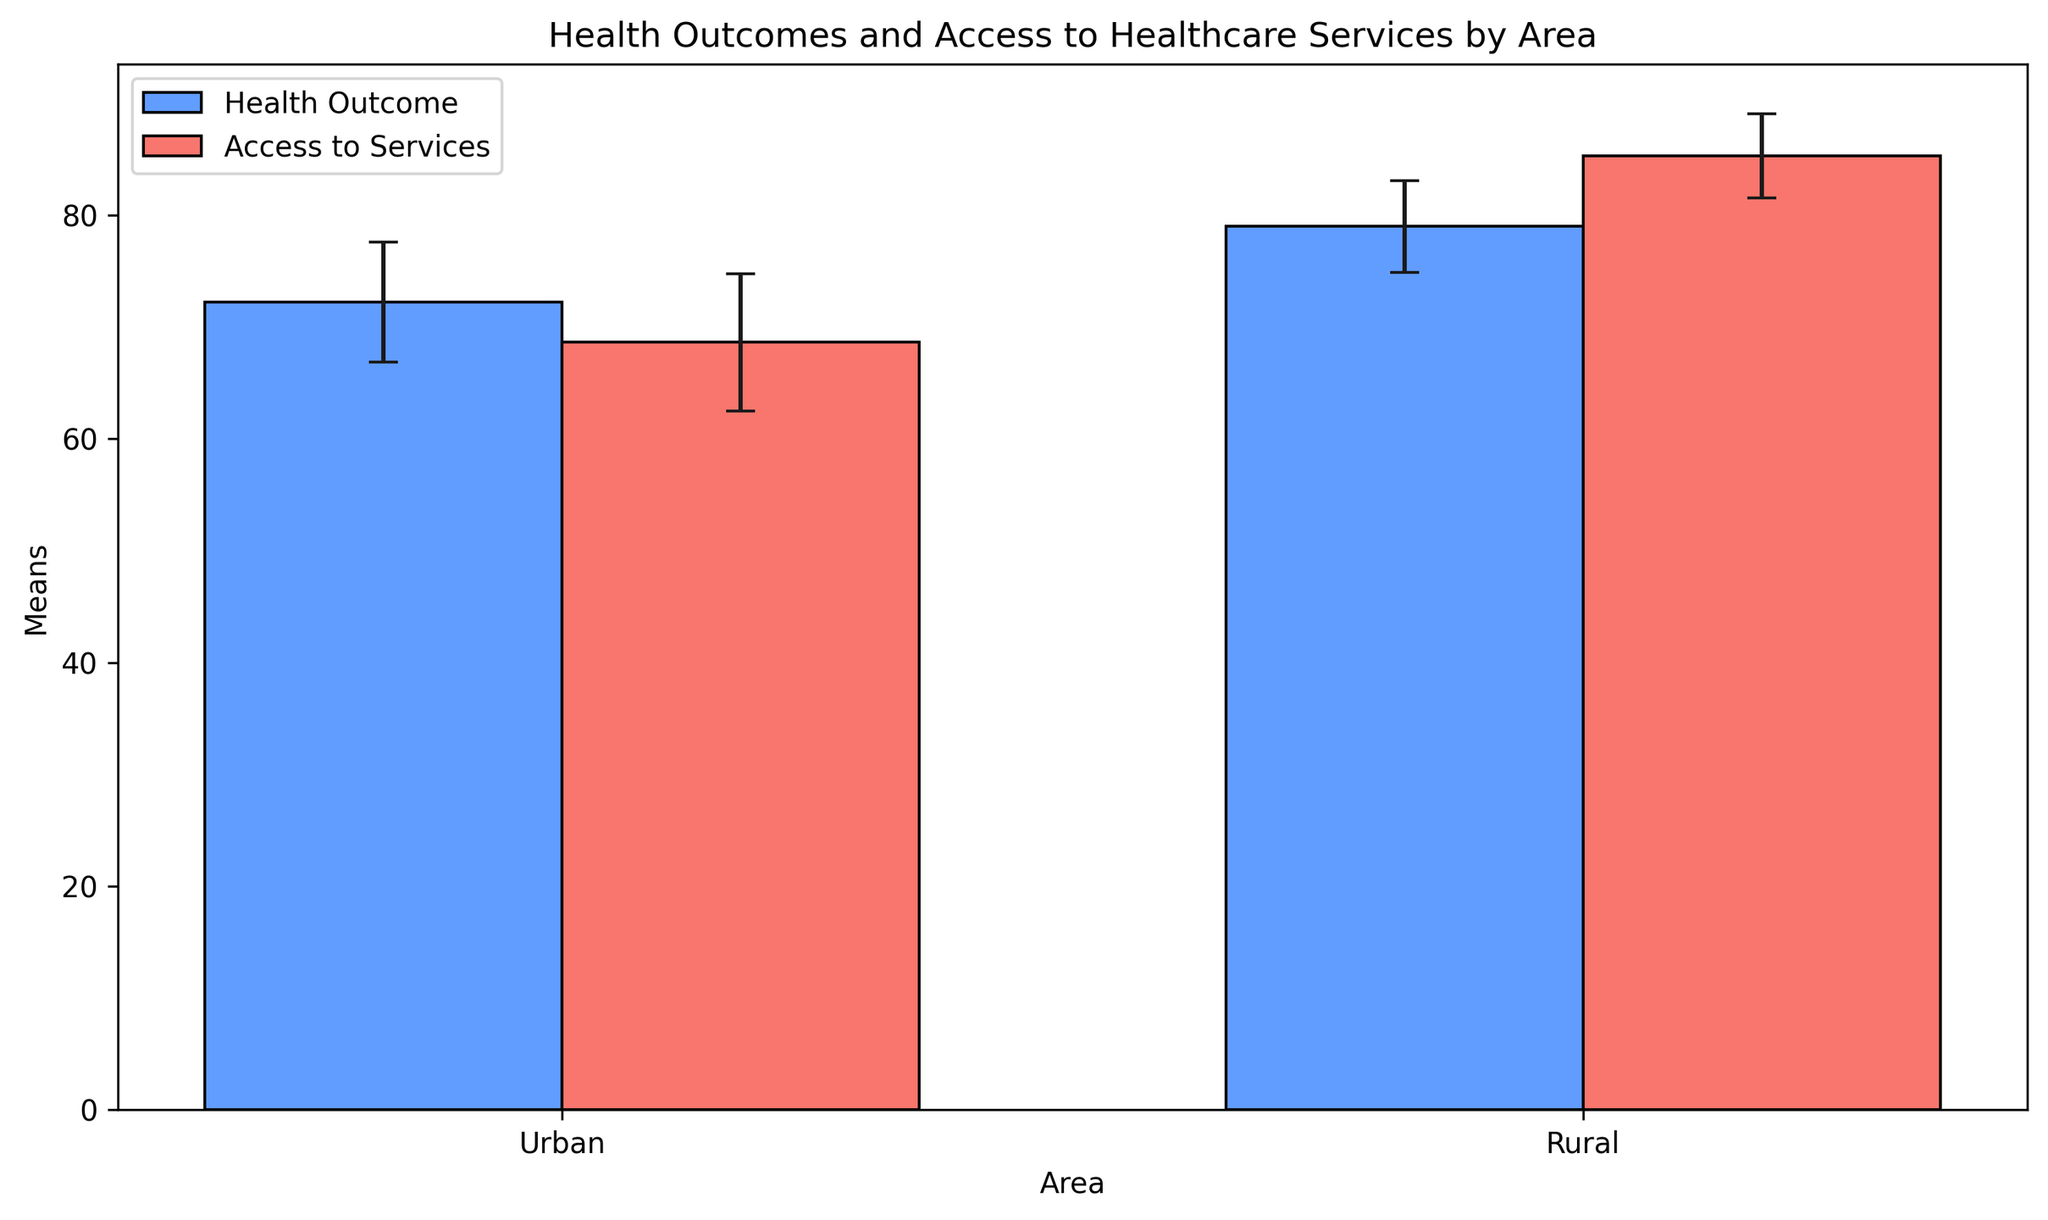What's the average health outcome mean for Urban areas? To find the average health outcome mean for Urban areas, add all the health outcome means for Urban areas (78.4, 79.2, 80.1, 77.9, 78.7, 79.6) and then divide by the number of data points (6). So, (78.4 + 79.2 + 80.1 + 77.9 + 78.7 + 79.6) / 6 = 78.98.
Answer: 78.98 How much higher is the average health outcome mean in Urban areas compared to Rural areas? Calculate the average health outcome for Urban areas (78.98) and Rural areas (72.2). Then, find the difference between the two values: 78.98 - 72.2 = 6.78.
Answer: 6.78 Which area has a higher mean value for access to healthcare services? Compare the mean values for access to healthcare services between Urban (85.3) and Rural (68.6) areas. The Urban area has a higher mean value.
Answer: Urban What color represents the bars for access to services in the figure? Observe the visual attributes of the bars in the figure. The bars representing access to services are colored in red.
Answer: Red What is the difference between the highest and lowest health outcome mean in Urban areas? Find the highest (80.1) and lowest (77.9) health outcome means for Urban areas. The difference is 80.1 - 77.9 = 2.2.
Answer: 2.2 Which area shows a wider error margin for access to healthcare services, and by how much? Compare the error margins for access to healthcare services in Urban (3.83) and Rural (6.13) areas. The Rural area shows a wider error margin by 6.13 - 3.83 = 2.3.
Answer: Rural, 2.3 Compare the average standard deviation for health outcomes between Urban and Rural areas. Which is higher? Calculate the average standard deviation for health outcomes in Urban areas (average of 4.1, 3.9, 4.5, 4.0, 3.8, and 4.2) and Rural areas (average of 5.3, 5.7, 5.1, 5.4, 5.2, and 5.5). Urban std = 4.083, Rural std = 5.37. The Rural area has a higher standard deviation.
Answer: Rural What is the average access to services mean in Rural areas? To calculate the average access to services mean for Rural areas, sum the access to services means for Rural areas (68.9, 67.5, 69.0, 70.1, 67.8, 68.5) and then divide by 6. So, (68.9 + 67.5 + 69.0 + 70.1 + 67.8 + 68.5) / 6 = 68.63.
Answer: 68.63 